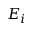<formula> <loc_0><loc_0><loc_500><loc_500>E _ { i }</formula> 